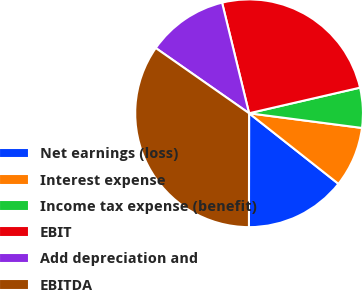Convert chart. <chart><loc_0><loc_0><loc_500><loc_500><pie_chart><fcel>Net earnings (loss)<fcel>Interest expense<fcel>Income tax expense (benefit)<fcel>EBIT<fcel>Add depreciation and<fcel>EBITDA<nl><fcel>14.38%<fcel>8.58%<fcel>5.67%<fcel>25.2%<fcel>11.48%<fcel>34.69%<nl></chart> 